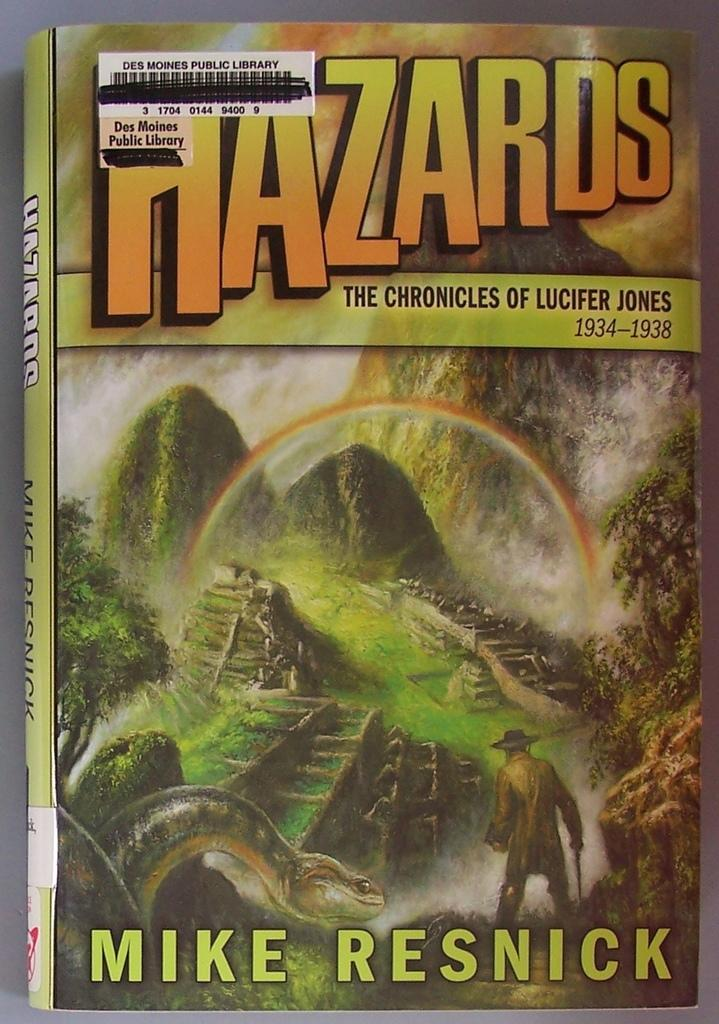<image>
Render a clear and concise summary of the photo. A book with a rainbow on it by Mike Resnick. 